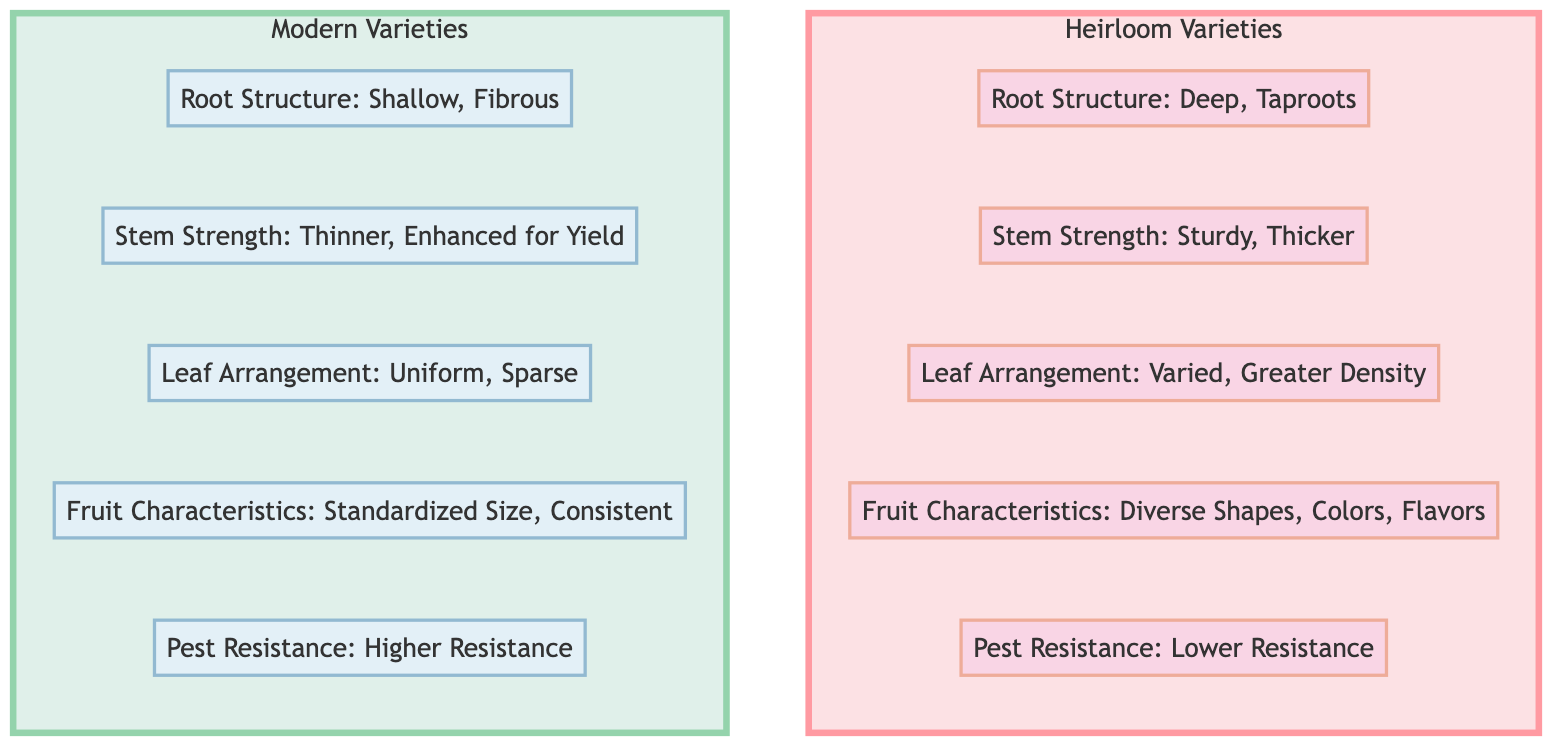What is the root structure of heirloom varieties? According to the diagram, heirloom varieties have a root structure characterized by deep taproots.
Answer: Deep, Taproots How many fruit characteristics are listed for modern varieties? The diagram shows one fruit characteristic listed for modern varieties, which is standardized size and consistent.
Answer: 1 Which variety has higher pest resistance? The diagram indicates that modern varieties have higher resistance to pests compared to heirloom varieties.
Answer: Higher Resistance What is the stem strength of modern varieties? The diagram outlines that the stem strength of modern varieties is thinner and enhanced for yield.
Answer: Thinner, Enhanced for Yield Which variety is noted for diverse fruit shapes? The diagram specifies that heirloom varieties are noted for diverse fruit shapes, colors, and flavors.
Answer: Heirloom What type of leaf arrangement do heirloom varieties have? The diagram details that heirloom varieties have varied leaf arrangement with greater density compared to modern varieties.
Answer: Varied, Greater Density How does the pest resistance of heirloom varieties compare to modern? The diagram compares pest resistance by indicating that heirloom varieties have lower resistance, while modern varieties have higher resistance. Therefore, heirloom varieties have lower pest resistance compared to modern varieties.
Answer: Lower Resistance What is a key difference in root structure between heirloom and modern varieties? The diagram distinguishes that heirloom varieties have deep taproots while modern varieties have a shallow, fibrous root structure. This highlights a clear contrast in their growth habits.
Answer: Shallow, Fibrous Which group shows more uniform leaf arrangement? The diagram indicates that modern varieties exhibit a uniform and sparse leaf arrangement, whereas heirloom varieties do not. Therefore, modern varieties show more uniform leaf arrangement.
Answer: Modern Varieties 